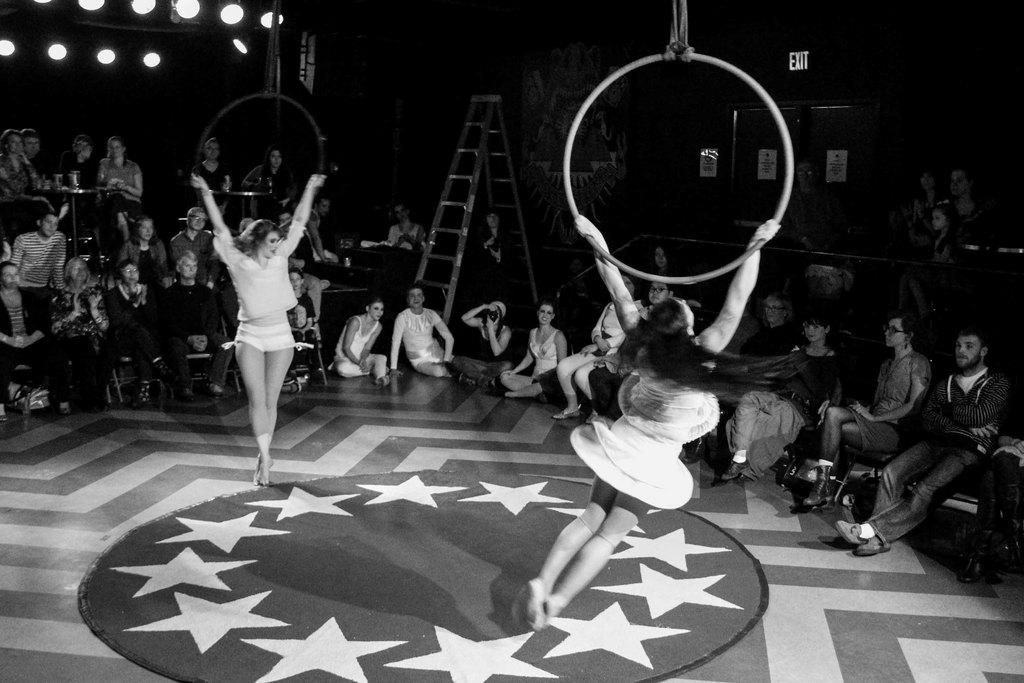How many people are in the image? There are two persons in the image. What are the two persons holding? The two persons are holding a ring. What can be seen in the background of the image? There is a group of people sitting in the background and a ladder. What is the color scheme of the image? The image is in black and white. What type of decision is being made by the persons holding the milk in the image? There is no milk present in the image, and therefore no decision-making involving milk can be observed. 